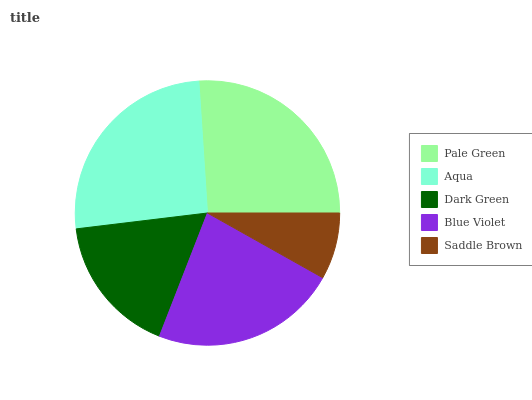Is Saddle Brown the minimum?
Answer yes or no. Yes. Is Pale Green the maximum?
Answer yes or no. Yes. Is Aqua the minimum?
Answer yes or no. No. Is Aqua the maximum?
Answer yes or no. No. Is Pale Green greater than Aqua?
Answer yes or no. Yes. Is Aqua less than Pale Green?
Answer yes or no. Yes. Is Aqua greater than Pale Green?
Answer yes or no. No. Is Pale Green less than Aqua?
Answer yes or no. No. Is Blue Violet the high median?
Answer yes or no. Yes. Is Blue Violet the low median?
Answer yes or no. Yes. Is Aqua the high median?
Answer yes or no. No. Is Pale Green the low median?
Answer yes or no. No. 